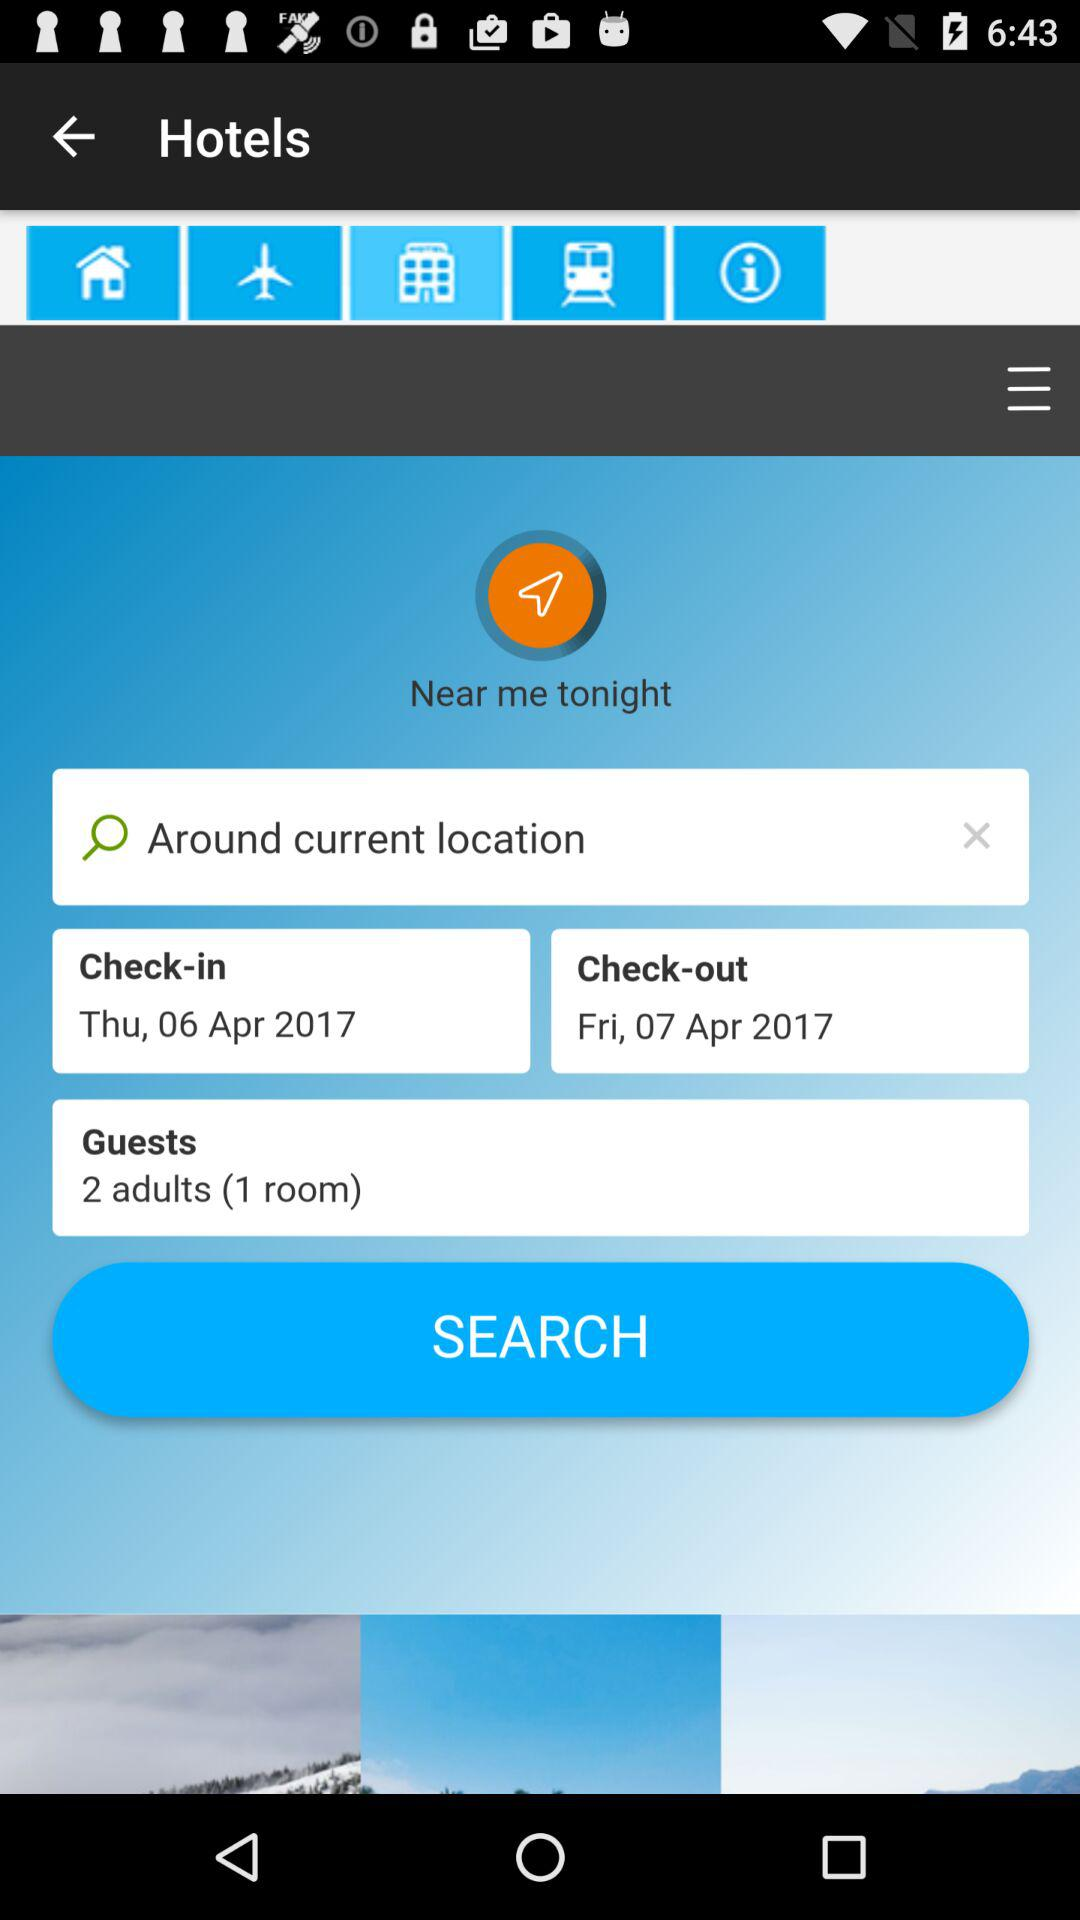What date is selected for check-out? The selected date for check-out is Friday, April 7, 2017. 